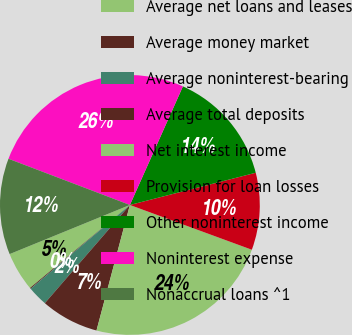Convert chart to OTSL. <chart><loc_0><loc_0><loc_500><loc_500><pie_chart><fcel>Average net loans and leases<fcel>Average money market<fcel>Average noninterest-bearing<fcel>Average total deposits<fcel>Net interest income<fcel>Provision for loan losses<fcel>Other noninterest income<fcel>Noninterest expense<fcel>Nonaccrual loans ^1<nl><fcel>4.86%<fcel>0.12%<fcel>2.49%<fcel>7.22%<fcel>23.54%<fcel>9.59%<fcel>14.32%<fcel>25.91%<fcel>11.96%<nl></chart> 